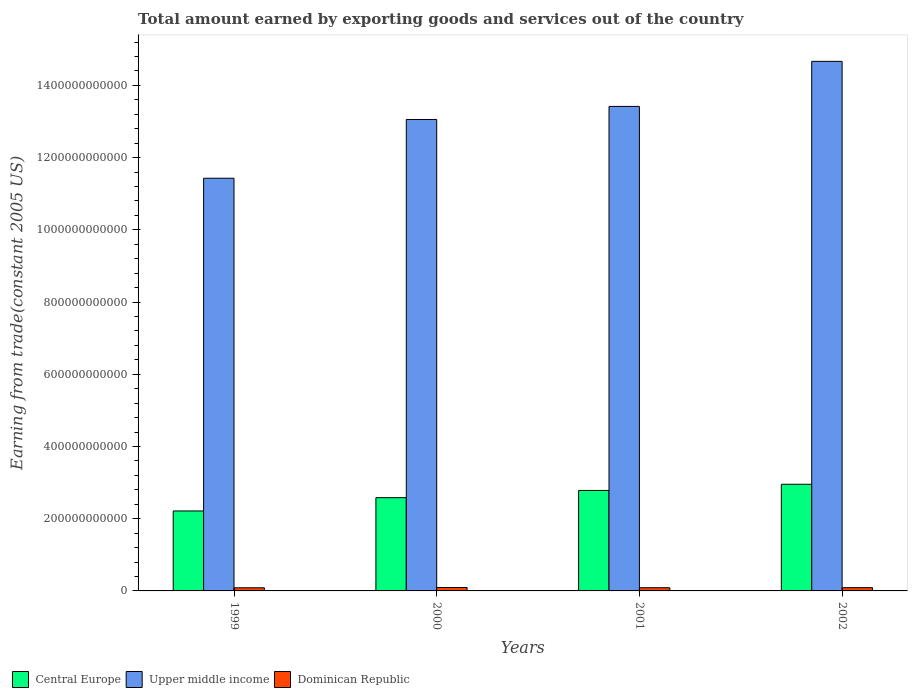Are the number of bars per tick equal to the number of legend labels?
Your answer should be compact. Yes. Are the number of bars on each tick of the X-axis equal?
Offer a very short reply. Yes. How many bars are there on the 1st tick from the right?
Keep it short and to the point. 3. What is the total amount earned by exporting goods and services in Dominican Republic in 2000?
Your answer should be compact. 9.42e+09. Across all years, what is the maximum total amount earned by exporting goods and services in Dominican Republic?
Offer a terse response. 9.42e+09. Across all years, what is the minimum total amount earned by exporting goods and services in Central Europe?
Your response must be concise. 2.21e+11. In which year was the total amount earned by exporting goods and services in Central Europe minimum?
Offer a very short reply. 1999. What is the total total amount earned by exporting goods and services in Dominican Republic in the graph?
Give a very brief answer. 3.60e+1. What is the difference between the total amount earned by exporting goods and services in Dominican Republic in 1999 and that in 2000?
Ensure brevity in your answer.  -7.57e+08. What is the difference between the total amount earned by exporting goods and services in Upper middle income in 2001 and the total amount earned by exporting goods and services in Dominican Republic in 2002?
Offer a very short reply. 1.33e+12. What is the average total amount earned by exporting goods and services in Central Europe per year?
Ensure brevity in your answer.  2.63e+11. In the year 1999, what is the difference between the total amount earned by exporting goods and services in Central Europe and total amount earned by exporting goods and services in Dominican Republic?
Offer a terse response. 2.13e+11. What is the ratio of the total amount earned by exporting goods and services in Central Europe in 2000 to that in 2001?
Your answer should be compact. 0.93. Is the total amount earned by exporting goods and services in Upper middle income in 2000 less than that in 2002?
Your response must be concise. Yes. Is the difference between the total amount earned by exporting goods and services in Central Europe in 2000 and 2001 greater than the difference between the total amount earned by exporting goods and services in Dominican Republic in 2000 and 2001?
Keep it short and to the point. No. What is the difference between the highest and the second highest total amount earned by exporting goods and services in Dominican Republic?
Provide a succinct answer. 4.01e+08. What is the difference between the highest and the lowest total amount earned by exporting goods and services in Dominican Republic?
Offer a very short reply. 7.57e+08. What does the 1st bar from the left in 2000 represents?
Provide a short and direct response. Central Europe. What does the 3rd bar from the right in 2002 represents?
Your response must be concise. Central Europe. Is it the case that in every year, the sum of the total amount earned by exporting goods and services in Upper middle income and total amount earned by exporting goods and services in Central Europe is greater than the total amount earned by exporting goods and services in Dominican Republic?
Offer a terse response. Yes. What is the difference between two consecutive major ticks on the Y-axis?
Provide a short and direct response. 2.00e+11. Are the values on the major ticks of Y-axis written in scientific E-notation?
Your answer should be very brief. No. Does the graph contain any zero values?
Your response must be concise. No. What is the title of the graph?
Give a very brief answer. Total amount earned by exporting goods and services out of the country. What is the label or title of the X-axis?
Provide a succinct answer. Years. What is the label or title of the Y-axis?
Offer a terse response. Earning from trade(constant 2005 US). What is the Earning from trade(constant 2005 US) in Central Europe in 1999?
Keep it short and to the point. 2.21e+11. What is the Earning from trade(constant 2005 US) of Upper middle income in 1999?
Offer a terse response. 1.14e+12. What is the Earning from trade(constant 2005 US) in Dominican Republic in 1999?
Your response must be concise. 8.67e+09. What is the Earning from trade(constant 2005 US) of Central Europe in 2000?
Ensure brevity in your answer.  2.58e+11. What is the Earning from trade(constant 2005 US) of Upper middle income in 2000?
Make the answer very short. 1.31e+12. What is the Earning from trade(constant 2005 US) of Dominican Republic in 2000?
Provide a short and direct response. 9.42e+09. What is the Earning from trade(constant 2005 US) of Central Europe in 2001?
Provide a short and direct response. 2.78e+11. What is the Earning from trade(constant 2005 US) of Upper middle income in 2001?
Ensure brevity in your answer.  1.34e+12. What is the Earning from trade(constant 2005 US) in Dominican Republic in 2001?
Provide a short and direct response. 8.85e+09. What is the Earning from trade(constant 2005 US) in Central Europe in 2002?
Offer a terse response. 2.95e+11. What is the Earning from trade(constant 2005 US) of Upper middle income in 2002?
Your response must be concise. 1.47e+12. What is the Earning from trade(constant 2005 US) in Dominican Republic in 2002?
Provide a short and direct response. 9.02e+09. Across all years, what is the maximum Earning from trade(constant 2005 US) of Central Europe?
Keep it short and to the point. 2.95e+11. Across all years, what is the maximum Earning from trade(constant 2005 US) in Upper middle income?
Give a very brief answer. 1.47e+12. Across all years, what is the maximum Earning from trade(constant 2005 US) of Dominican Republic?
Ensure brevity in your answer.  9.42e+09. Across all years, what is the minimum Earning from trade(constant 2005 US) of Central Europe?
Ensure brevity in your answer.  2.21e+11. Across all years, what is the minimum Earning from trade(constant 2005 US) of Upper middle income?
Your response must be concise. 1.14e+12. Across all years, what is the minimum Earning from trade(constant 2005 US) of Dominican Republic?
Offer a terse response. 8.67e+09. What is the total Earning from trade(constant 2005 US) in Central Europe in the graph?
Ensure brevity in your answer.  1.05e+12. What is the total Earning from trade(constant 2005 US) in Upper middle income in the graph?
Your answer should be compact. 5.26e+12. What is the total Earning from trade(constant 2005 US) of Dominican Republic in the graph?
Provide a short and direct response. 3.60e+1. What is the difference between the Earning from trade(constant 2005 US) of Central Europe in 1999 and that in 2000?
Your answer should be compact. -3.68e+1. What is the difference between the Earning from trade(constant 2005 US) of Upper middle income in 1999 and that in 2000?
Offer a very short reply. -1.63e+11. What is the difference between the Earning from trade(constant 2005 US) in Dominican Republic in 1999 and that in 2000?
Ensure brevity in your answer.  -7.57e+08. What is the difference between the Earning from trade(constant 2005 US) of Central Europe in 1999 and that in 2001?
Your answer should be very brief. -5.69e+1. What is the difference between the Earning from trade(constant 2005 US) in Upper middle income in 1999 and that in 2001?
Your answer should be compact. -1.99e+11. What is the difference between the Earning from trade(constant 2005 US) of Dominican Republic in 1999 and that in 2001?
Provide a succinct answer. -1.81e+08. What is the difference between the Earning from trade(constant 2005 US) in Central Europe in 1999 and that in 2002?
Offer a very short reply. -7.39e+1. What is the difference between the Earning from trade(constant 2005 US) in Upper middle income in 1999 and that in 2002?
Your answer should be compact. -3.24e+11. What is the difference between the Earning from trade(constant 2005 US) of Dominican Republic in 1999 and that in 2002?
Your answer should be compact. -3.56e+08. What is the difference between the Earning from trade(constant 2005 US) in Central Europe in 2000 and that in 2001?
Give a very brief answer. -2.01e+1. What is the difference between the Earning from trade(constant 2005 US) in Upper middle income in 2000 and that in 2001?
Offer a terse response. -3.62e+1. What is the difference between the Earning from trade(constant 2005 US) in Dominican Republic in 2000 and that in 2001?
Keep it short and to the point. 5.76e+08. What is the difference between the Earning from trade(constant 2005 US) of Central Europe in 2000 and that in 2002?
Your answer should be compact. -3.71e+1. What is the difference between the Earning from trade(constant 2005 US) in Upper middle income in 2000 and that in 2002?
Give a very brief answer. -1.61e+11. What is the difference between the Earning from trade(constant 2005 US) of Dominican Republic in 2000 and that in 2002?
Provide a succinct answer. 4.01e+08. What is the difference between the Earning from trade(constant 2005 US) in Central Europe in 2001 and that in 2002?
Give a very brief answer. -1.70e+1. What is the difference between the Earning from trade(constant 2005 US) in Upper middle income in 2001 and that in 2002?
Keep it short and to the point. -1.25e+11. What is the difference between the Earning from trade(constant 2005 US) of Dominican Republic in 2001 and that in 2002?
Provide a succinct answer. -1.75e+08. What is the difference between the Earning from trade(constant 2005 US) of Central Europe in 1999 and the Earning from trade(constant 2005 US) of Upper middle income in 2000?
Your answer should be compact. -1.08e+12. What is the difference between the Earning from trade(constant 2005 US) of Central Europe in 1999 and the Earning from trade(constant 2005 US) of Dominican Republic in 2000?
Give a very brief answer. 2.12e+11. What is the difference between the Earning from trade(constant 2005 US) of Upper middle income in 1999 and the Earning from trade(constant 2005 US) of Dominican Republic in 2000?
Provide a succinct answer. 1.13e+12. What is the difference between the Earning from trade(constant 2005 US) of Central Europe in 1999 and the Earning from trade(constant 2005 US) of Upper middle income in 2001?
Make the answer very short. -1.12e+12. What is the difference between the Earning from trade(constant 2005 US) in Central Europe in 1999 and the Earning from trade(constant 2005 US) in Dominican Republic in 2001?
Ensure brevity in your answer.  2.13e+11. What is the difference between the Earning from trade(constant 2005 US) of Upper middle income in 1999 and the Earning from trade(constant 2005 US) of Dominican Republic in 2001?
Provide a short and direct response. 1.13e+12. What is the difference between the Earning from trade(constant 2005 US) in Central Europe in 1999 and the Earning from trade(constant 2005 US) in Upper middle income in 2002?
Offer a very short reply. -1.25e+12. What is the difference between the Earning from trade(constant 2005 US) in Central Europe in 1999 and the Earning from trade(constant 2005 US) in Dominican Republic in 2002?
Provide a succinct answer. 2.12e+11. What is the difference between the Earning from trade(constant 2005 US) of Upper middle income in 1999 and the Earning from trade(constant 2005 US) of Dominican Republic in 2002?
Provide a succinct answer. 1.13e+12. What is the difference between the Earning from trade(constant 2005 US) of Central Europe in 2000 and the Earning from trade(constant 2005 US) of Upper middle income in 2001?
Your response must be concise. -1.08e+12. What is the difference between the Earning from trade(constant 2005 US) of Central Europe in 2000 and the Earning from trade(constant 2005 US) of Dominican Republic in 2001?
Offer a terse response. 2.49e+11. What is the difference between the Earning from trade(constant 2005 US) of Upper middle income in 2000 and the Earning from trade(constant 2005 US) of Dominican Republic in 2001?
Offer a terse response. 1.30e+12. What is the difference between the Earning from trade(constant 2005 US) of Central Europe in 2000 and the Earning from trade(constant 2005 US) of Upper middle income in 2002?
Offer a terse response. -1.21e+12. What is the difference between the Earning from trade(constant 2005 US) of Central Europe in 2000 and the Earning from trade(constant 2005 US) of Dominican Republic in 2002?
Make the answer very short. 2.49e+11. What is the difference between the Earning from trade(constant 2005 US) in Upper middle income in 2000 and the Earning from trade(constant 2005 US) in Dominican Republic in 2002?
Offer a terse response. 1.30e+12. What is the difference between the Earning from trade(constant 2005 US) of Central Europe in 2001 and the Earning from trade(constant 2005 US) of Upper middle income in 2002?
Offer a very short reply. -1.19e+12. What is the difference between the Earning from trade(constant 2005 US) of Central Europe in 2001 and the Earning from trade(constant 2005 US) of Dominican Republic in 2002?
Offer a terse response. 2.69e+11. What is the difference between the Earning from trade(constant 2005 US) in Upper middle income in 2001 and the Earning from trade(constant 2005 US) in Dominican Republic in 2002?
Provide a succinct answer. 1.33e+12. What is the average Earning from trade(constant 2005 US) of Central Europe per year?
Keep it short and to the point. 2.63e+11. What is the average Earning from trade(constant 2005 US) of Upper middle income per year?
Your response must be concise. 1.31e+12. What is the average Earning from trade(constant 2005 US) of Dominican Republic per year?
Provide a succinct answer. 8.99e+09. In the year 1999, what is the difference between the Earning from trade(constant 2005 US) in Central Europe and Earning from trade(constant 2005 US) in Upper middle income?
Provide a succinct answer. -9.21e+11. In the year 1999, what is the difference between the Earning from trade(constant 2005 US) of Central Europe and Earning from trade(constant 2005 US) of Dominican Republic?
Ensure brevity in your answer.  2.13e+11. In the year 1999, what is the difference between the Earning from trade(constant 2005 US) in Upper middle income and Earning from trade(constant 2005 US) in Dominican Republic?
Your answer should be very brief. 1.13e+12. In the year 2000, what is the difference between the Earning from trade(constant 2005 US) in Central Europe and Earning from trade(constant 2005 US) in Upper middle income?
Provide a short and direct response. -1.05e+12. In the year 2000, what is the difference between the Earning from trade(constant 2005 US) in Central Europe and Earning from trade(constant 2005 US) in Dominican Republic?
Make the answer very short. 2.49e+11. In the year 2000, what is the difference between the Earning from trade(constant 2005 US) in Upper middle income and Earning from trade(constant 2005 US) in Dominican Republic?
Provide a short and direct response. 1.30e+12. In the year 2001, what is the difference between the Earning from trade(constant 2005 US) in Central Europe and Earning from trade(constant 2005 US) in Upper middle income?
Give a very brief answer. -1.06e+12. In the year 2001, what is the difference between the Earning from trade(constant 2005 US) in Central Europe and Earning from trade(constant 2005 US) in Dominican Republic?
Your answer should be compact. 2.69e+11. In the year 2001, what is the difference between the Earning from trade(constant 2005 US) in Upper middle income and Earning from trade(constant 2005 US) in Dominican Republic?
Offer a very short reply. 1.33e+12. In the year 2002, what is the difference between the Earning from trade(constant 2005 US) of Central Europe and Earning from trade(constant 2005 US) of Upper middle income?
Make the answer very short. -1.17e+12. In the year 2002, what is the difference between the Earning from trade(constant 2005 US) of Central Europe and Earning from trade(constant 2005 US) of Dominican Republic?
Provide a succinct answer. 2.86e+11. In the year 2002, what is the difference between the Earning from trade(constant 2005 US) in Upper middle income and Earning from trade(constant 2005 US) in Dominican Republic?
Provide a succinct answer. 1.46e+12. What is the ratio of the Earning from trade(constant 2005 US) of Central Europe in 1999 to that in 2000?
Offer a terse response. 0.86. What is the ratio of the Earning from trade(constant 2005 US) in Upper middle income in 1999 to that in 2000?
Offer a very short reply. 0.88. What is the ratio of the Earning from trade(constant 2005 US) in Dominican Republic in 1999 to that in 2000?
Offer a very short reply. 0.92. What is the ratio of the Earning from trade(constant 2005 US) of Central Europe in 1999 to that in 2001?
Your answer should be compact. 0.8. What is the ratio of the Earning from trade(constant 2005 US) of Upper middle income in 1999 to that in 2001?
Keep it short and to the point. 0.85. What is the ratio of the Earning from trade(constant 2005 US) in Dominican Republic in 1999 to that in 2001?
Offer a terse response. 0.98. What is the ratio of the Earning from trade(constant 2005 US) of Central Europe in 1999 to that in 2002?
Keep it short and to the point. 0.75. What is the ratio of the Earning from trade(constant 2005 US) of Upper middle income in 1999 to that in 2002?
Your answer should be compact. 0.78. What is the ratio of the Earning from trade(constant 2005 US) in Dominican Republic in 1999 to that in 2002?
Offer a very short reply. 0.96. What is the ratio of the Earning from trade(constant 2005 US) in Central Europe in 2000 to that in 2001?
Ensure brevity in your answer.  0.93. What is the ratio of the Earning from trade(constant 2005 US) of Upper middle income in 2000 to that in 2001?
Your answer should be very brief. 0.97. What is the ratio of the Earning from trade(constant 2005 US) of Dominican Republic in 2000 to that in 2001?
Your answer should be very brief. 1.07. What is the ratio of the Earning from trade(constant 2005 US) of Central Europe in 2000 to that in 2002?
Offer a terse response. 0.87. What is the ratio of the Earning from trade(constant 2005 US) in Upper middle income in 2000 to that in 2002?
Ensure brevity in your answer.  0.89. What is the ratio of the Earning from trade(constant 2005 US) of Dominican Republic in 2000 to that in 2002?
Offer a very short reply. 1.04. What is the ratio of the Earning from trade(constant 2005 US) of Central Europe in 2001 to that in 2002?
Your answer should be very brief. 0.94. What is the ratio of the Earning from trade(constant 2005 US) of Upper middle income in 2001 to that in 2002?
Your answer should be compact. 0.91. What is the ratio of the Earning from trade(constant 2005 US) in Dominican Republic in 2001 to that in 2002?
Provide a short and direct response. 0.98. What is the difference between the highest and the second highest Earning from trade(constant 2005 US) in Central Europe?
Provide a succinct answer. 1.70e+1. What is the difference between the highest and the second highest Earning from trade(constant 2005 US) in Upper middle income?
Your response must be concise. 1.25e+11. What is the difference between the highest and the second highest Earning from trade(constant 2005 US) in Dominican Republic?
Ensure brevity in your answer.  4.01e+08. What is the difference between the highest and the lowest Earning from trade(constant 2005 US) in Central Europe?
Give a very brief answer. 7.39e+1. What is the difference between the highest and the lowest Earning from trade(constant 2005 US) in Upper middle income?
Keep it short and to the point. 3.24e+11. What is the difference between the highest and the lowest Earning from trade(constant 2005 US) in Dominican Republic?
Provide a short and direct response. 7.57e+08. 